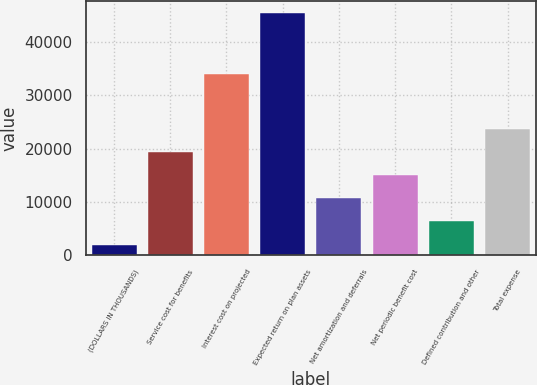Convert chart. <chart><loc_0><loc_0><loc_500><loc_500><bar_chart><fcel>(DOLLARS IN THOUSANDS)<fcel>Service cost for benefits<fcel>Interest cost on projected<fcel>Expected return on plan assets<fcel>Net amortization and deferrals<fcel>Net periodic benefit cost<fcel>Defined contribution and other<fcel>Total expense<nl><fcel>2011<fcel>19361<fcel>34033<fcel>45386<fcel>10686<fcel>15023.5<fcel>6348.5<fcel>23698.5<nl></chart> 